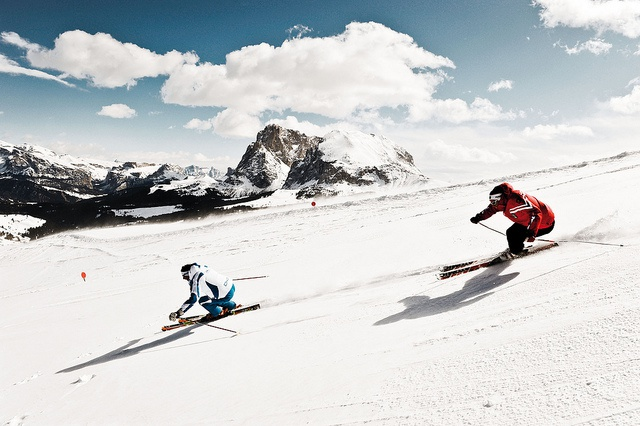Describe the objects in this image and their specific colors. I can see people in blue, black, maroon, white, and brown tones, people in blue, white, black, darkblue, and darkgray tones, skis in blue, black, lightgray, maroon, and gray tones, and skis in blue, black, gray, darkgray, and maroon tones in this image. 